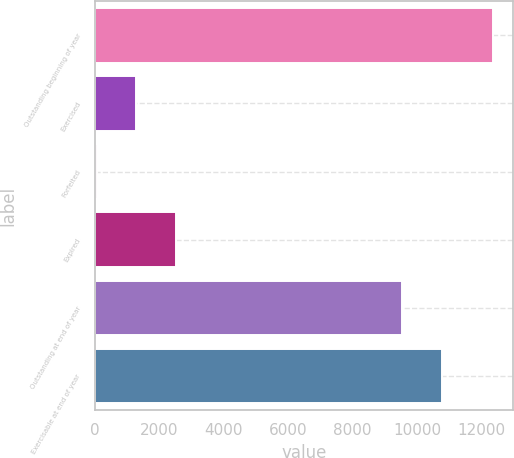Convert chart. <chart><loc_0><loc_0><loc_500><loc_500><bar_chart><fcel>Outstanding beginning of year<fcel>Exercised<fcel>Forfeited<fcel>Expired<fcel>Outstanding at end of year<fcel>Exercisable at end of year<nl><fcel>12374<fcel>1282.4<fcel>50<fcel>2514.8<fcel>9547<fcel>10779.4<nl></chart> 